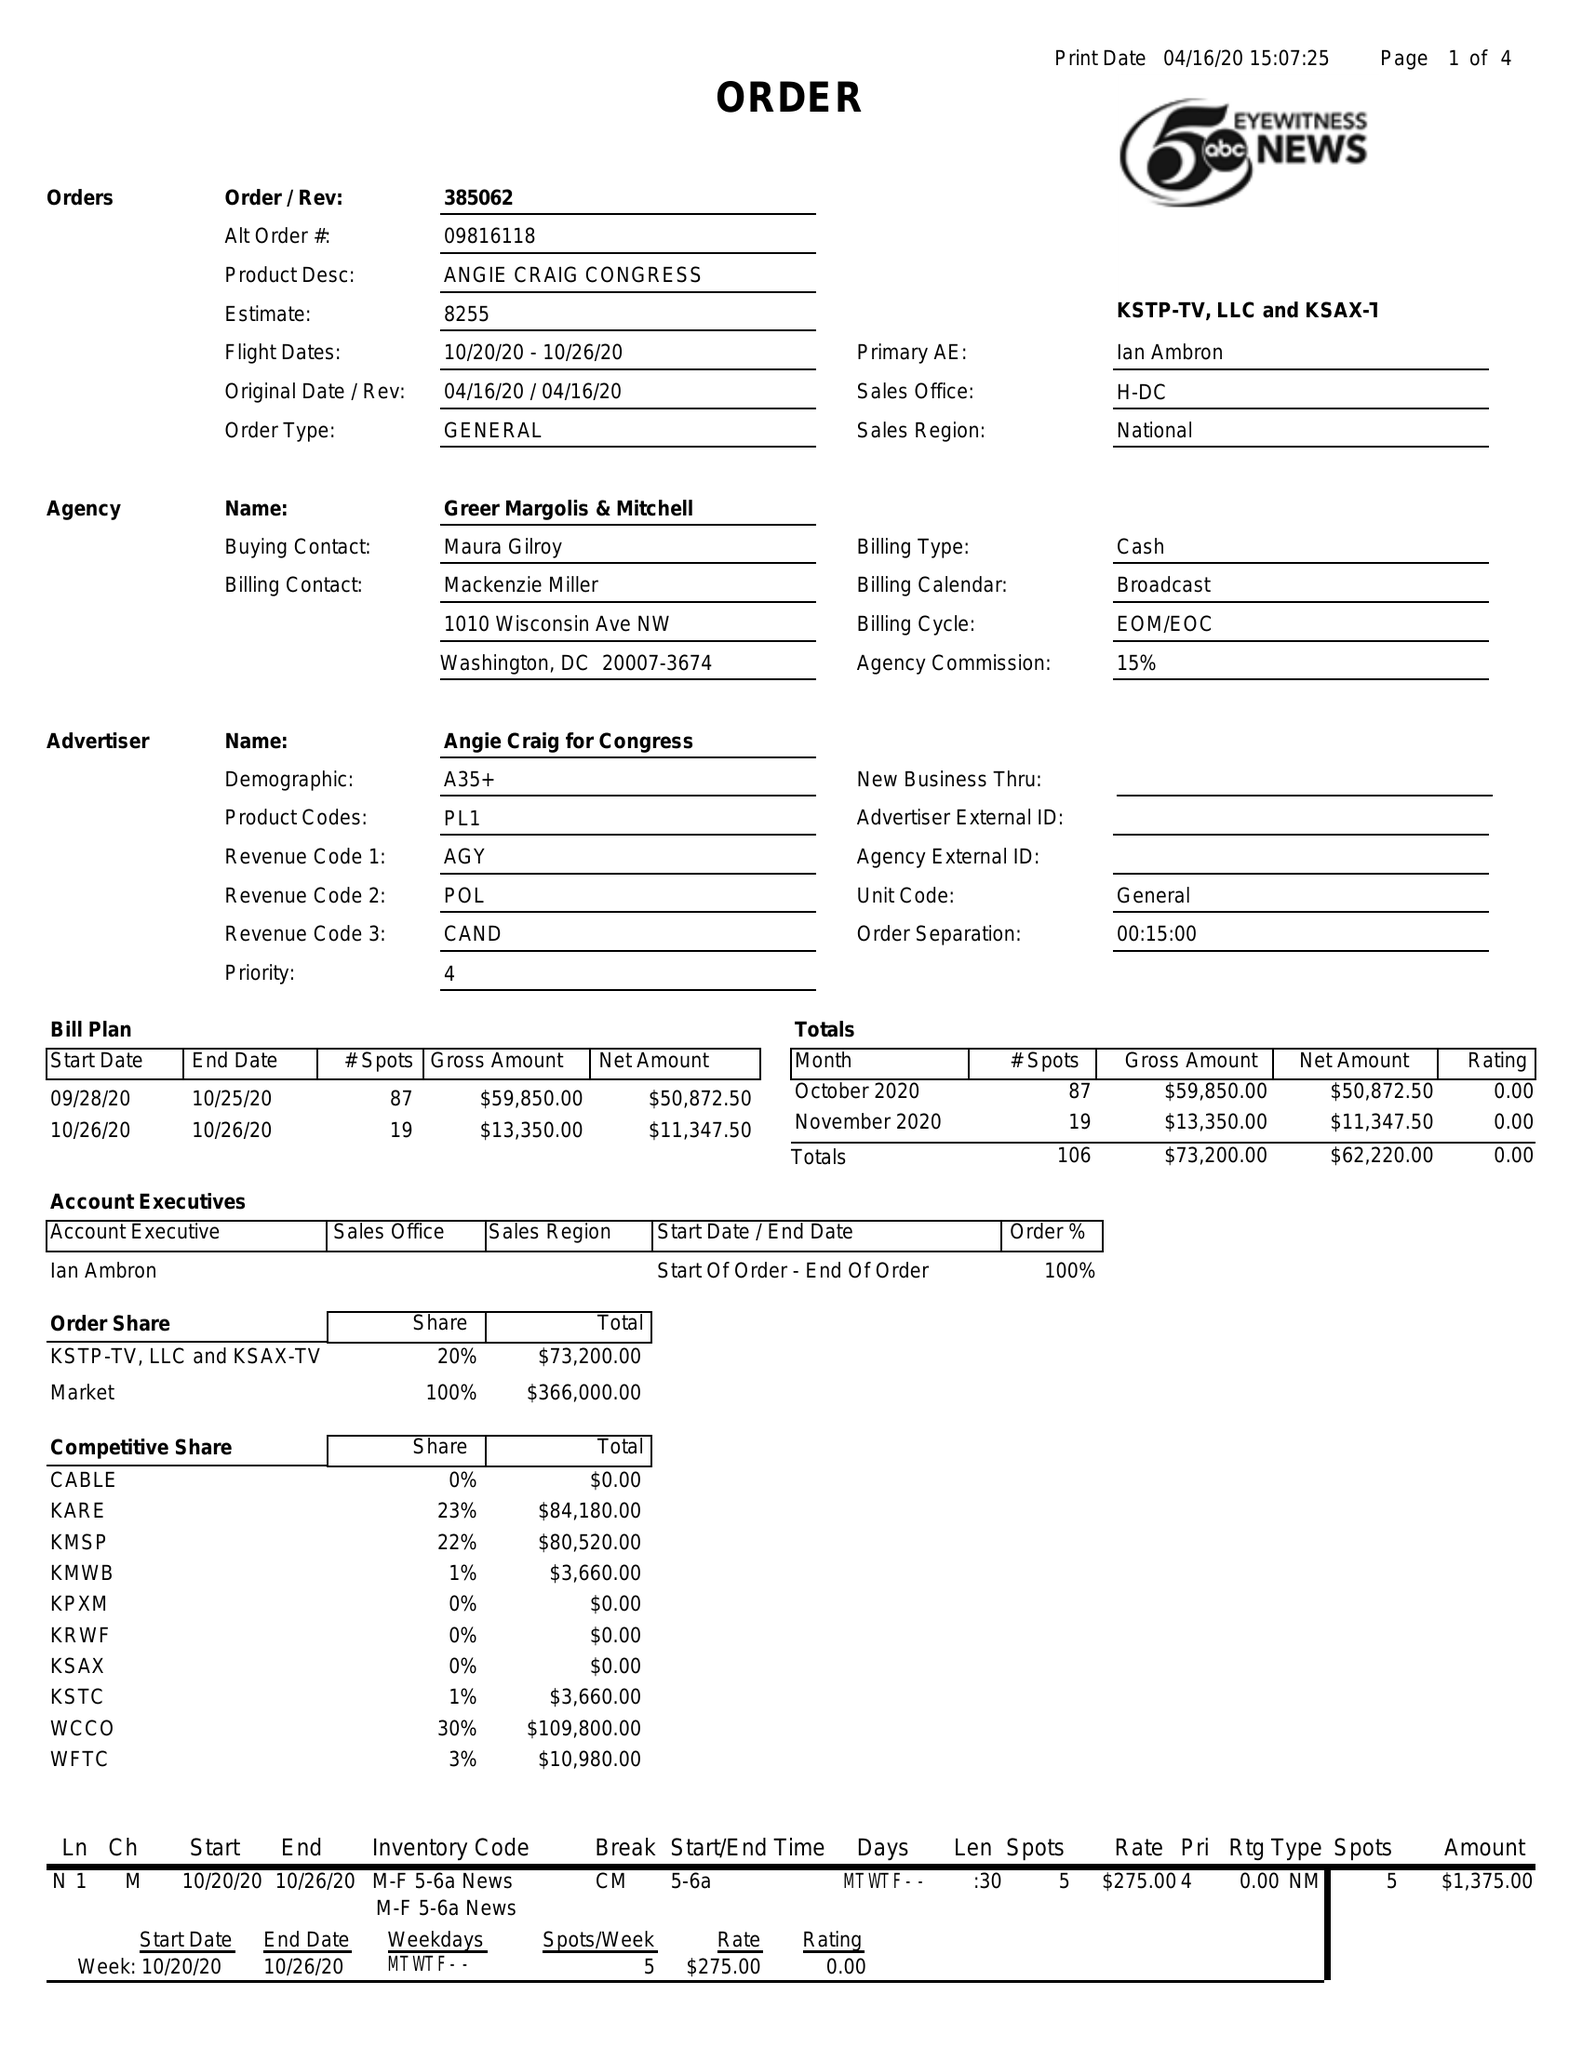What is the value for the gross_amount?
Answer the question using a single word or phrase. 73200.00 